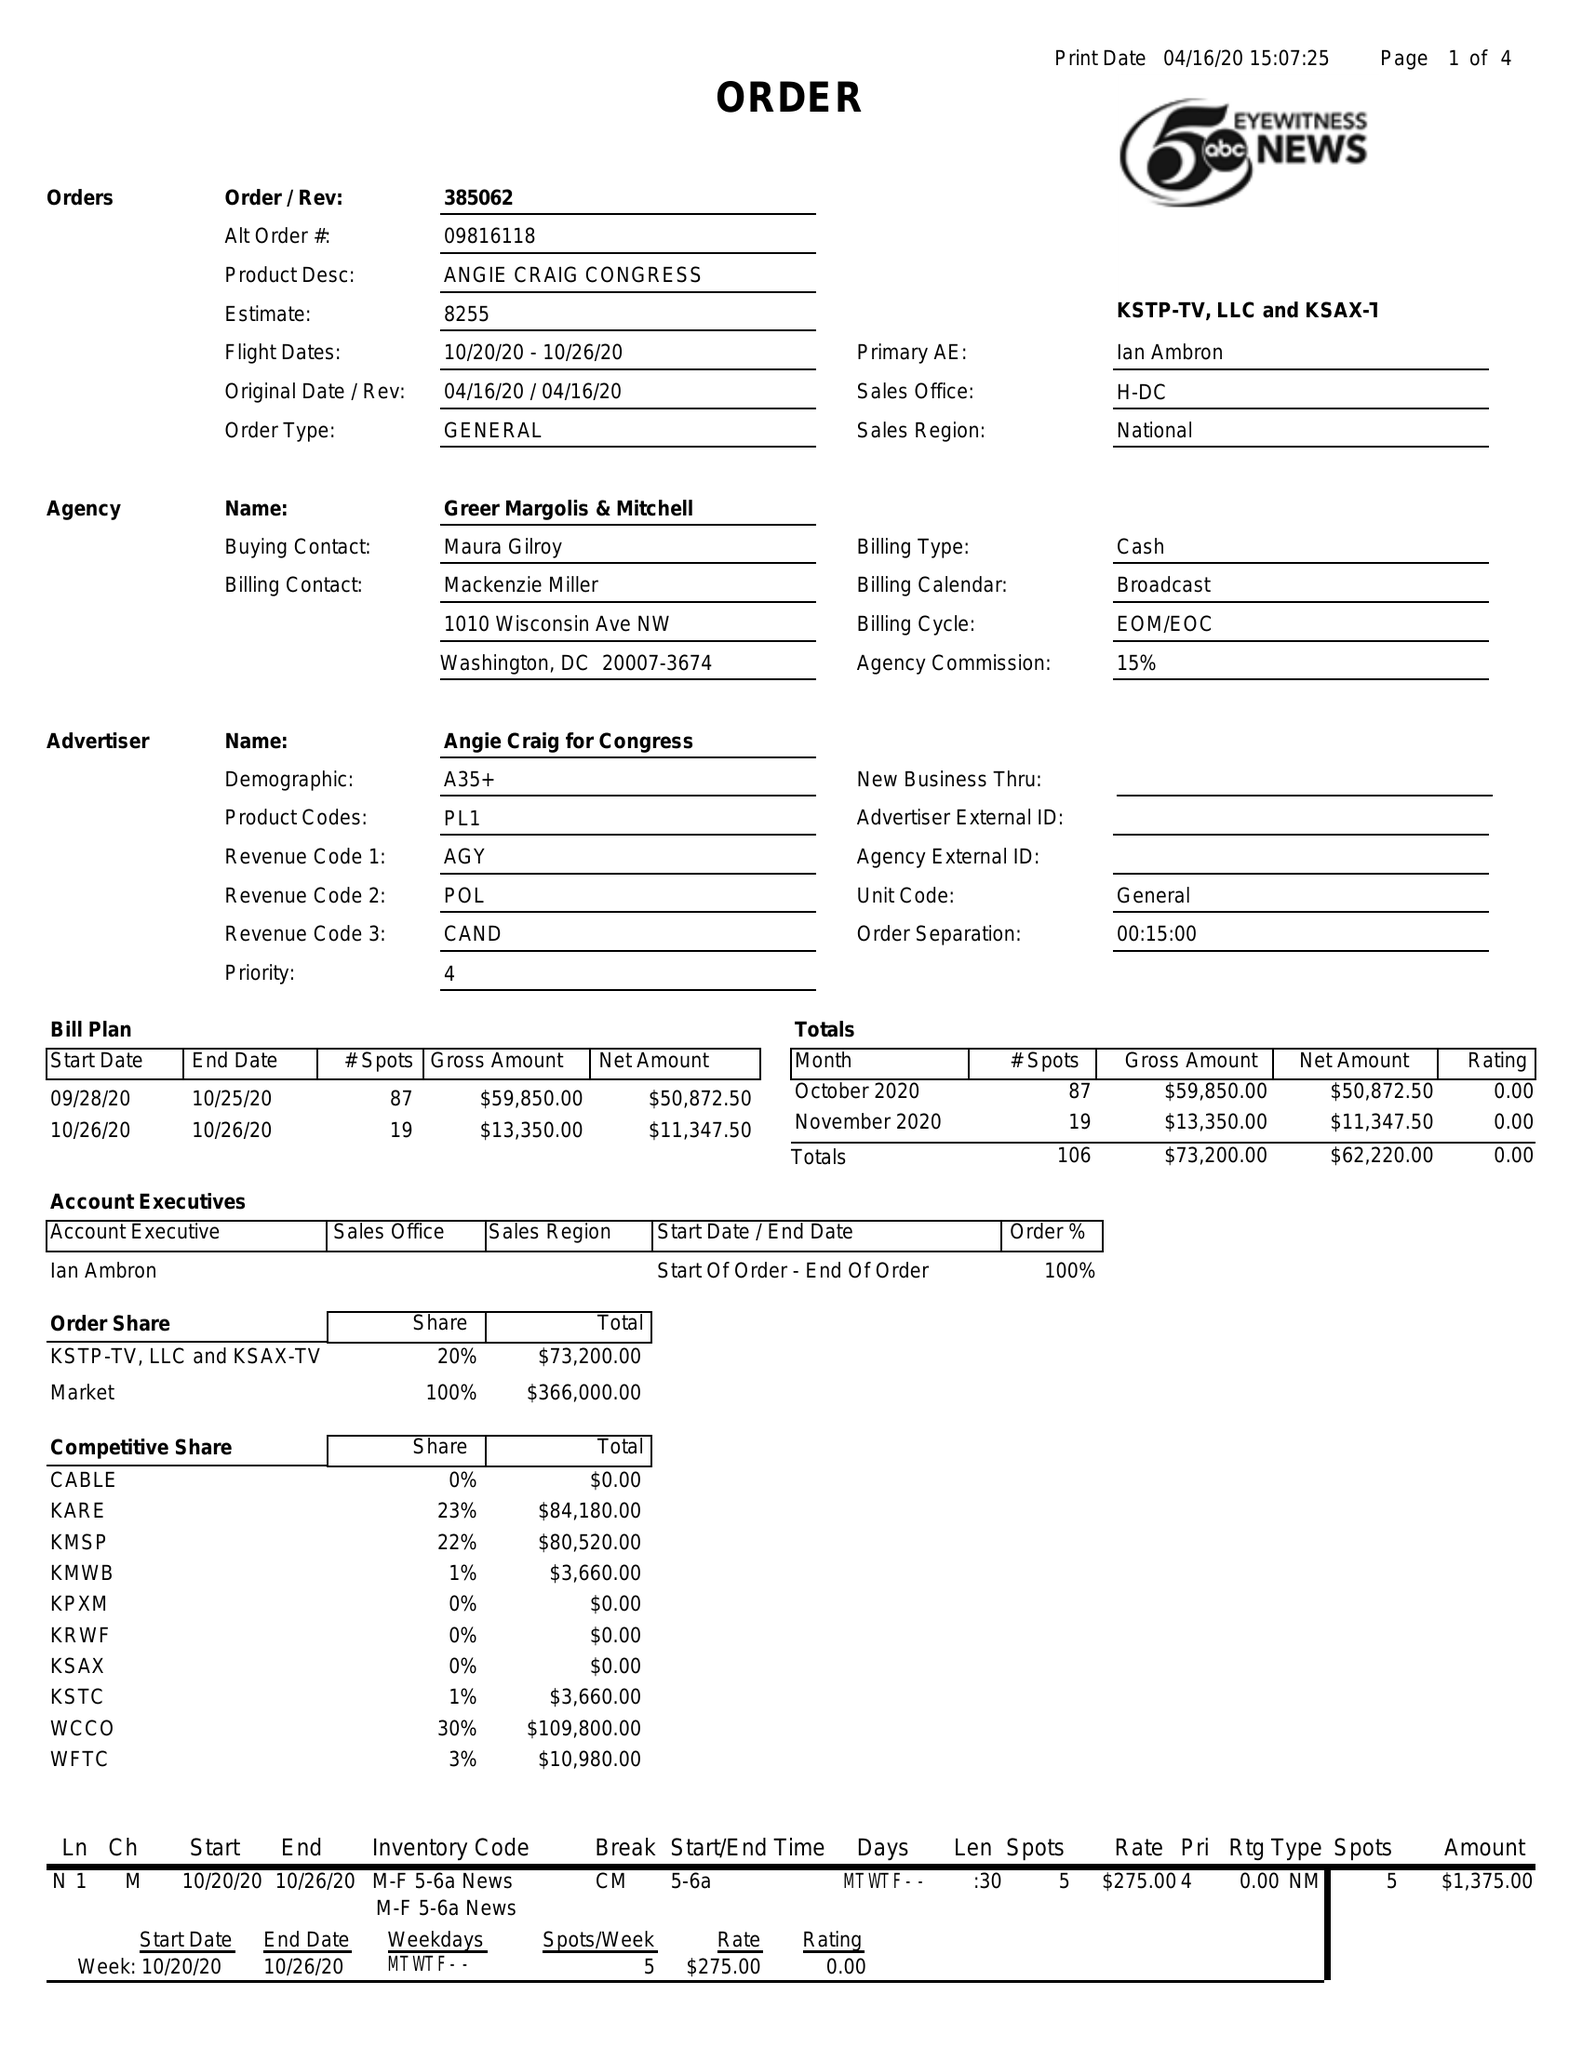What is the value for the gross_amount?
Answer the question using a single word or phrase. 73200.00 